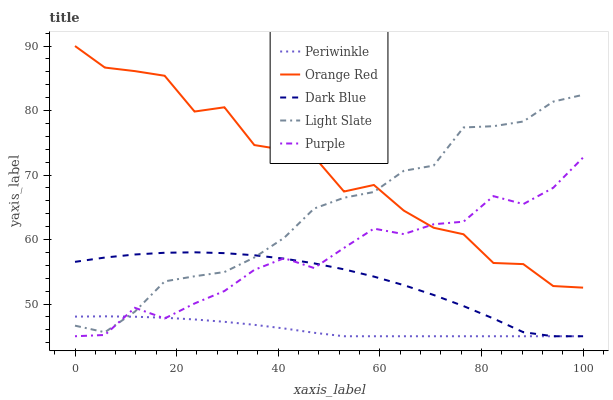Does Periwinkle have the minimum area under the curve?
Answer yes or no. Yes. Does Orange Red have the maximum area under the curve?
Answer yes or no. Yes. Does Dark Blue have the minimum area under the curve?
Answer yes or no. No. Does Dark Blue have the maximum area under the curve?
Answer yes or no. No. Is Periwinkle the smoothest?
Answer yes or no. Yes. Is Orange Red the roughest?
Answer yes or no. Yes. Is Dark Blue the smoothest?
Answer yes or no. No. Is Dark Blue the roughest?
Answer yes or no. No. Does Dark Blue have the lowest value?
Answer yes or no. Yes. Does Orange Red have the lowest value?
Answer yes or no. No. Does Orange Red have the highest value?
Answer yes or no. Yes. Does Dark Blue have the highest value?
Answer yes or no. No. Is Periwinkle less than Orange Red?
Answer yes or no. Yes. Is Orange Red greater than Dark Blue?
Answer yes or no. Yes. Does Dark Blue intersect Periwinkle?
Answer yes or no. Yes. Is Dark Blue less than Periwinkle?
Answer yes or no. No. Is Dark Blue greater than Periwinkle?
Answer yes or no. No. Does Periwinkle intersect Orange Red?
Answer yes or no. No. 